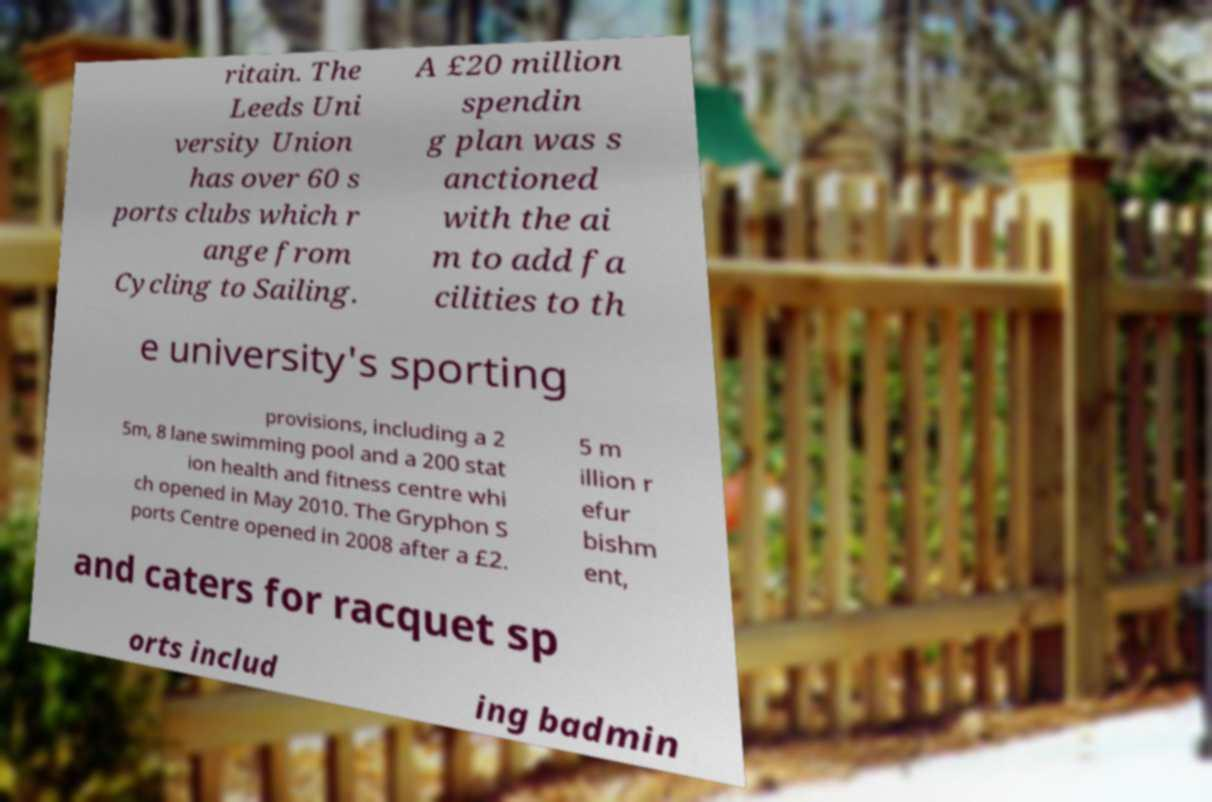For documentation purposes, I need the text within this image transcribed. Could you provide that? ritain. The Leeds Uni versity Union has over 60 s ports clubs which r ange from Cycling to Sailing. A £20 million spendin g plan was s anctioned with the ai m to add fa cilities to th e university's sporting provisions, including a 2 5m, 8 lane swimming pool and a 200 stat ion health and fitness centre whi ch opened in May 2010. The Gryphon S ports Centre opened in 2008 after a £2. 5 m illion r efur bishm ent, and caters for racquet sp orts includ ing badmin 